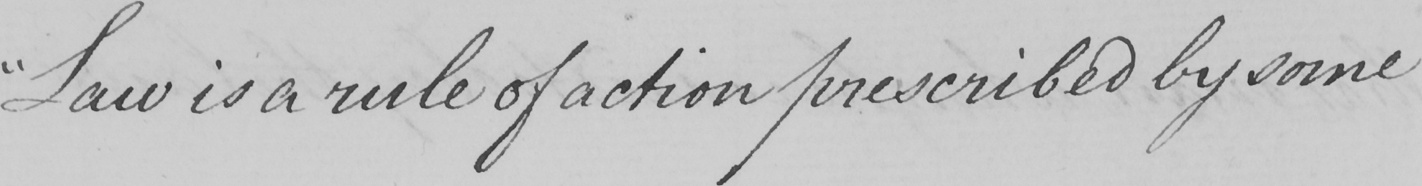Please provide the text content of this handwritten line. " Law is a rule of action prescribed by some 